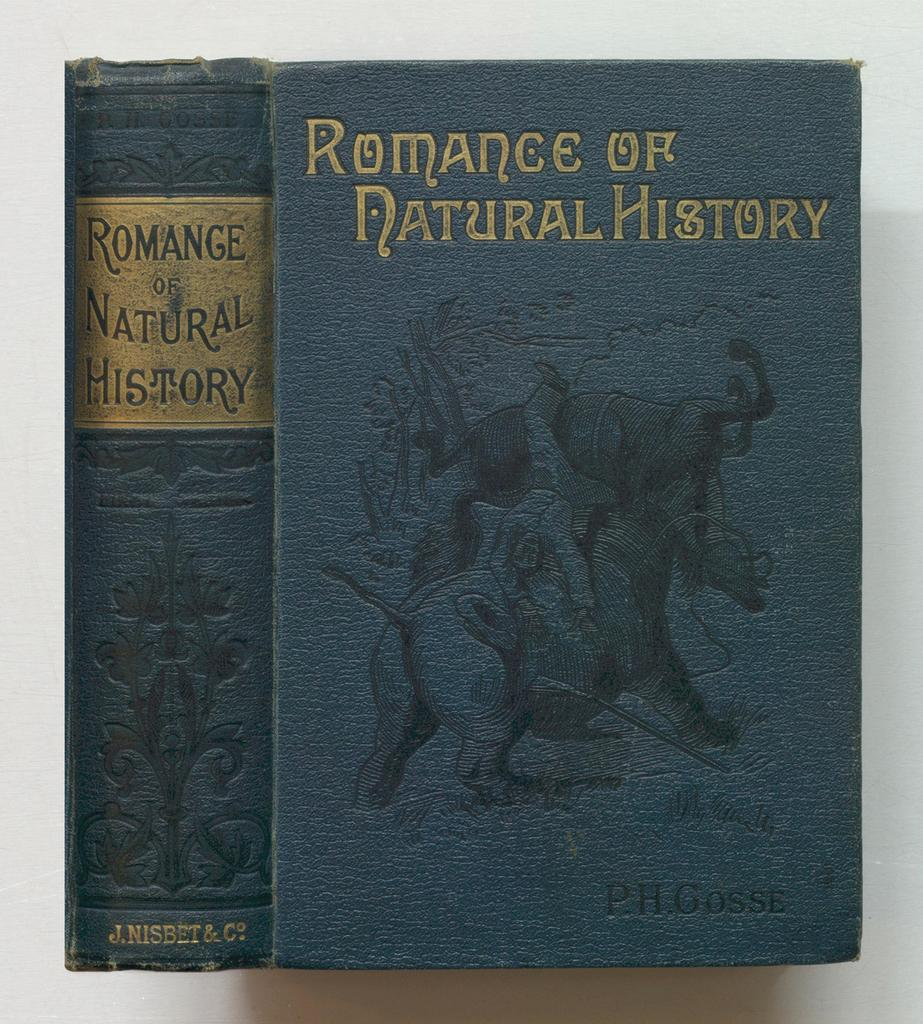<image>
Render a clear and concise summary of the photo. An old book cover reads Romance of Natural History. 